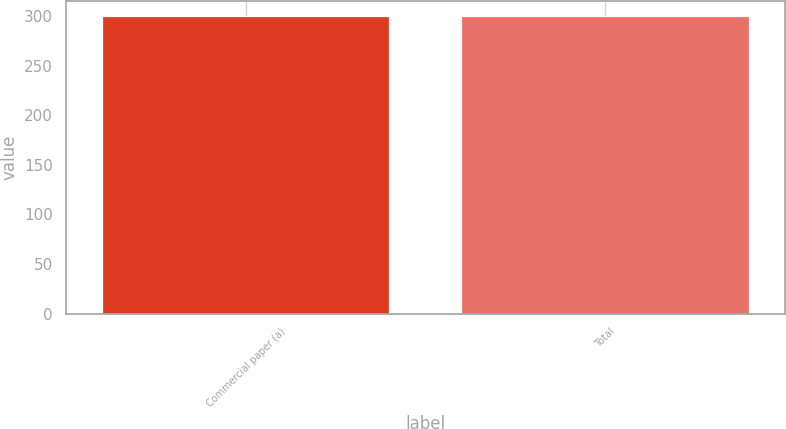Convert chart. <chart><loc_0><loc_0><loc_500><loc_500><bar_chart><fcel>Commercial paper (a)<fcel>Total<nl><fcel>300<fcel>300.1<nl></chart> 